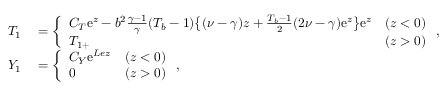Convert formula to latex. <formula><loc_0><loc_0><loc_500><loc_500>\begin{array} { r l } { { T } _ { 1 } } & = \left \{ \begin{array} { l l l } { C _ { T } e ^ { z } - b ^ { 2 } \frac { \gamma - 1 } { \gamma } ( T _ { b } - 1 ) \left \{ ( \nu - \gamma ) z + \frac { T _ { b } - 1 } { 2 } ( 2 \nu - \gamma ) e ^ { z } \right \} e ^ { z } } & { ( z < 0 ) } \\ { { T } _ { 1 + } } & { ( z > 0 ) } \end{array} , } \\ { { Y } _ { 1 } } & = \left \{ \begin{array} { l l l } { C _ { Y } e ^ { L e z } } & { ( z < 0 ) } \\ { 0 } & { ( z > 0 ) } \end{array} , } \end{array}</formula> 